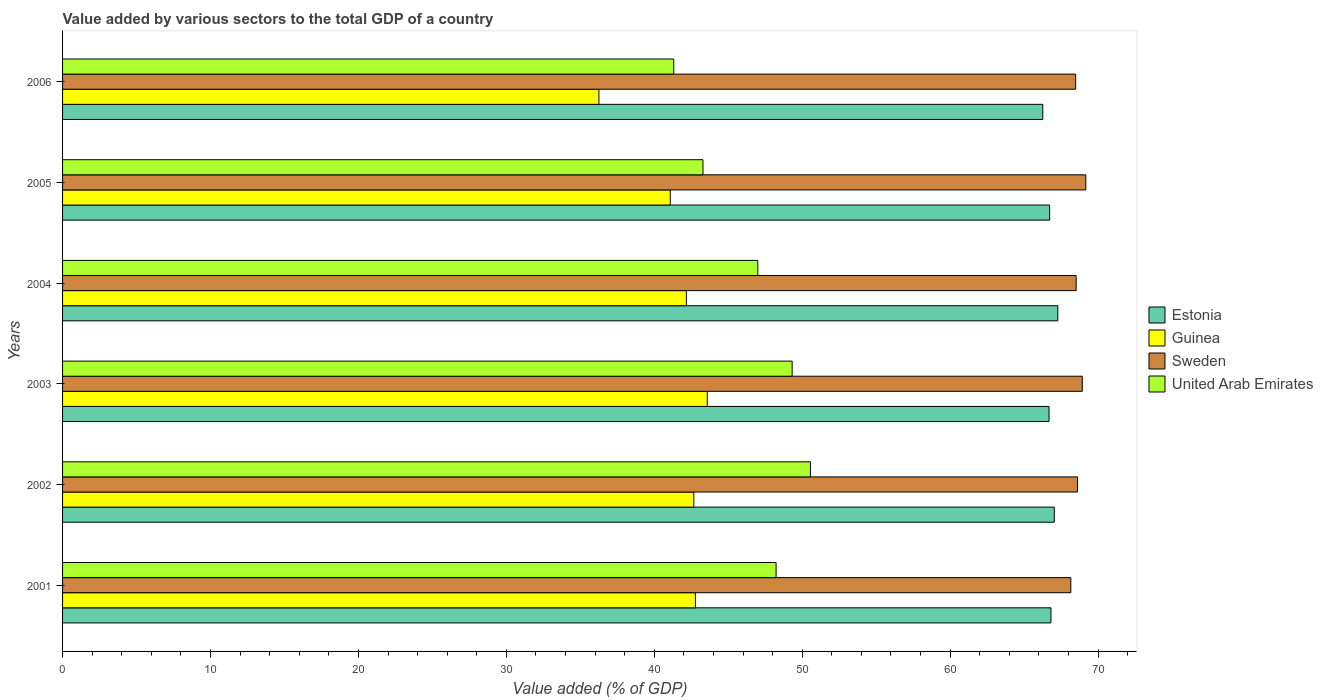How many different coloured bars are there?
Your answer should be very brief. 4. How many groups of bars are there?
Your answer should be very brief. 6. What is the value added by various sectors to the total GDP in United Arab Emirates in 2002?
Your answer should be very brief. 50.56. Across all years, what is the maximum value added by various sectors to the total GDP in Estonia?
Your answer should be compact. 67.28. Across all years, what is the minimum value added by various sectors to the total GDP in Estonia?
Keep it short and to the point. 66.26. In which year was the value added by various sectors to the total GDP in Guinea minimum?
Your answer should be very brief. 2006. What is the total value added by various sectors to the total GDP in Guinea in the graph?
Provide a succinct answer. 248.54. What is the difference between the value added by various sectors to the total GDP in Sweden in 2005 and that in 2006?
Make the answer very short. 0.69. What is the difference between the value added by various sectors to the total GDP in Guinea in 2004 and the value added by various sectors to the total GDP in Estonia in 2006?
Offer a very short reply. -24.09. What is the average value added by various sectors to the total GDP in Estonia per year?
Your answer should be very brief. 66.8. In the year 2003, what is the difference between the value added by various sectors to the total GDP in Guinea and value added by various sectors to the total GDP in Estonia?
Provide a succinct answer. -23.1. In how many years, is the value added by various sectors to the total GDP in Estonia greater than 32 %?
Offer a terse response. 6. What is the ratio of the value added by various sectors to the total GDP in Sweden in 2001 to that in 2003?
Ensure brevity in your answer.  0.99. Is the value added by various sectors to the total GDP in Guinea in 2003 less than that in 2004?
Make the answer very short. No. What is the difference between the highest and the second highest value added by various sectors to the total GDP in United Arab Emirates?
Offer a very short reply. 1.24. What is the difference between the highest and the lowest value added by various sectors to the total GDP in United Arab Emirates?
Your answer should be very brief. 9.24. In how many years, is the value added by various sectors to the total GDP in United Arab Emirates greater than the average value added by various sectors to the total GDP in United Arab Emirates taken over all years?
Provide a succinct answer. 4. What does the 4th bar from the top in 2005 represents?
Offer a very short reply. Estonia. What does the 1st bar from the bottom in 2003 represents?
Keep it short and to the point. Estonia. How many years are there in the graph?
Offer a very short reply. 6. Does the graph contain any zero values?
Offer a very short reply. No. Does the graph contain grids?
Provide a short and direct response. No. Where does the legend appear in the graph?
Keep it short and to the point. Center right. How many legend labels are there?
Provide a succinct answer. 4. How are the legend labels stacked?
Your answer should be very brief. Vertical. What is the title of the graph?
Provide a succinct answer. Value added by various sectors to the total GDP of a country. What is the label or title of the X-axis?
Your response must be concise. Value added (% of GDP). What is the label or title of the Y-axis?
Make the answer very short. Years. What is the Value added (% of GDP) in Estonia in 2001?
Provide a succinct answer. 66.81. What is the Value added (% of GDP) in Guinea in 2001?
Offer a terse response. 42.78. What is the Value added (% of GDP) of Sweden in 2001?
Your answer should be compact. 68.16. What is the Value added (% of GDP) of United Arab Emirates in 2001?
Provide a short and direct response. 48.23. What is the Value added (% of GDP) in Estonia in 2002?
Provide a succinct answer. 67.04. What is the Value added (% of GDP) in Guinea in 2002?
Make the answer very short. 42.67. What is the Value added (% of GDP) in Sweden in 2002?
Keep it short and to the point. 68.61. What is the Value added (% of GDP) in United Arab Emirates in 2002?
Offer a very short reply. 50.56. What is the Value added (% of GDP) of Estonia in 2003?
Make the answer very short. 66.68. What is the Value added (% of GDP) of Guinea in 2003?
Give a very brief answer. 43.58. What is the Value added (% of GDP) of Sweden in 2003?
Ensure brevity in your answer.  68.93. What is the Value added (% of GDP) of United Arab Emirates in 2003?
Provide a succinct answer. 49.32. What is the Value added (% of GDP) in Estonia in 2004?
Give a very brief answer. 67.28. What is the Value added (% of GDP) in Guinea in 2004?
Your answer should be compact. 42.17. What is the Value added (% of GDP) of Sweden in 2004?
Offer a very short reply. 68.52. What is the Value added (% of GDP) of United Arab Emirates in 2004?
Give a very brief answer. 47. What is the Value added (% of GDP) of Estonia in 2005?
Provide a short and direct response. 66.72. What is the Value added (% of GDP) of Guinea in 2005?
Provide a succinct answer. 41.08. What is the Value added (% of GDP) in Sweden in 2005?
Your answer should be very brief. 69.17. What is the Value added (% of GDP) of United Arab Emirates in 2005?
Keep it short and to the point. 43.29. What is the Value added (% of GDP) of Estonia in 2006?
Provide a short and direct response. 66.26. What is the Value added (% of GDP) of Guinea in 2006?
Offer a very short reply. 36.26. What is the Value added (% of GDP) of Sweden in 2006?
Your response must be concise. 68.48. What is the Value added (% of GDP) of United Arab Emirates in 2006?
Offer a terse response. 41.32. Across all years, what is the maximum Value added (% of GDP) in Estonia?
Your answer should be compact. 67.28. Across all years, what is the maximum Value added (% of GDP) of Guinea?
Give a very brief answer. 43.58. Across all years, what is the maximum Value added (% of GDP) of Sweden?
Your response must be concise. 69.17. Across all years, what is the maximum Value added (% of GDP) in United Arab Emirates?
Your answer should be compact. 50.56. Across all years, what is the minimum Value added (% of GDP) in Estonia?
Your answer should be compact. 66.26. Across all years, what is the minimum Value added (% of GDP) of Guinea?
Your answer should be compact. 36.26. Across all years, what is the minimum Value added (% of GDP) of Sweden?
Give a very brief answer. 68.16. Across all years, what is the minimum Value added (% of GDP) in United Arab Emirates?
Give a very brief answer. 41.32. What is the total Value added (% of GDP) of Estonia in the graph?
Provide a short and direct response. 400.8. What is the total Value added (% of GDP) of Guinea in the graph?
Provide a short and direct response. 248.54. What is the total Value added (% of GDP) of Sweden in the graph?
Your response must be concise. 411.87. What is the total Value added (% of GDP) of United Arab Emirates in the graph?
Offer a terse response. 279.71. What is the difference between the Value added (% of GDP) in Estonia in 2001 and that in 2002?
Your answer should be compact. -0.22. What is the difference between the Value added (% of GDP) in Guinea in 2001 and that in 2002?
Your answer should be compact. 0.11. What is the difference between the Value added (% of GDP) in Sweden in 2001 and that in 2002?
Offer a terse response. -0.45. What is the difference between the Value added (% of GDP) of United Arab Emirates in 2001 and that in 2002?
Offer a very short reply. -2.32. What is the difference between the Value added (% of GDP) of Estonia in 2001 and that in 2003?
Provide a short and direct response. 0.13. What is the difference between the Value added (% of GDP) in Guinea in 2001 and that in 2003?
Your answer should be very brief. -0.8. What is the difference between the Value added (% of GDP) of Sweden in 2001 and that in 2003?
Ensure brevity in your answer.  -0.78. What is the difference between the Value added (% of GDP) in United Arab Emirates in 2001 and that in 2003?
Offer a terse response. -1.08. What is the difference between the Value added (% of GDP) of Estonia in 2001 and that in 2004?
Provide a succinct answer. -0.46. What is the difference between the Value added (% of GDP) of Guinea in 2001 and that in 2004?
Provide a short and direct response. 0.61. What is the difference between the Value added (% of GDP) in Sweden in 2001 and that in 2004?
Your answer should be very brief. -0.36. What is the difference between the Value added (% of GDP) in United Arab Emirates in 2001 and that in 2004?
Provide a short and direct response. 1.24. What is the difference between the Value added (% of GDP) of Estonia in 2001 and that in 2005?
Your answer should be compact. 0.09. What is the difference between the Value added (% of GDP) of Guinea in 2001 and that in 2005?
Your response must be concise. 1.7. What is the difference between the Value added (% of GDP) in Sweden in 2001 and that in 2005?
Offer a terse response. -1.01. What is the difference between the Value added (% of GDP) of United Arab Emirates in 2001 and that in 2005?
Your answer should be very brief. 4.94. What is the difference between the Value added (% of GDP) in Estonia in 2001 and that in 2006?
Keep it short and to the point. 0.55. What is the difference between the Value added (% of GDP) in Guinea in 2001 and that in 2006?
Make the answer very short. 6.52. What is the difference between the Value added (% of GDP) of Sweden in 2001 and that in 2006?
Ensure brevity in your answer.  -0.33. What is the difference between the Value added (% of GDP) in United Arab Emirates in 2001 and that in 2006?
Provide a succinct answer. 6.92. What is the difference between the Value added (% of GDP) in Estonia in 2002 and that in 2003?
Keep it short and to the point. 0.35. What is the difference between the Value added (% of GDP) of Guinea in 2002 and that in 2003?
Make the answer very short. -0.91. What is the difference between the Value added (% of GDP) of Sweden in 2002 and that in 2003?
Provide a succinct answer. -0.32. What is the difference between the Value added (% of GDP) of United Arab Emirates in 2002 and that in 2003?
Make the answer very short. 1.24. What is the difference between the Value added (% of GDP) in Estonia in 2002 and that in 2004?
Provide a succinct answer. -0.24. What is the difference between the Value added (% of GDP) in Guinea in 2002 and that in 2004?
Make the answer very short. 0.5. What is the difference between the Value added (% of GDP) of Sweden in 2002 and that in 2004?
Your answer should be very brief. 0.09. What is the difference between the Value added (% of GDP) of United Arab Emirates in 2002 and that in 2004?
Your answer should be very brief. 3.56. What is the difference between the Value added (% of GDP) of Estonia in 2002 and that in 2005?
Provide a short and direct response. 0.31. What is the difference between the Value added (% of GDP) of Guinea in 2002 and that in 2005?
Make the answer very short. 1.59. What is the difference between the Value added (% of GDP) of Sweden in 2002 and that in 2005?
Provide a succinct answer. -0.56. What is the difference between the Value added (% of GDP) of United Arab Emirates in 2002 and that in 2005?
Your response must be concise. 7.26. What is the difference between the Value added (% of GDP) of Estonia in 2002 and that in 2006?
Ensure brevity in your answer.  0.78. What is the difference between the Value added (% of GDP) of Guinea in 2002 and that in 2006?
Provide a short and direct response. 6.42. What is the difference between the Value added (% of GDP) of Sweden in 2002 and that in 2006?
Provide a succinct answer. 0.13. What is the difference between the Value added (% of GDP) in United Arab Emirates in 2002 and that in 2006?
Your response must be concise. 9.24. What is the difference between the Value added (% of GDP) in Estonia in 2003 and that in 2004?
Your answer should be very brief. -0.59. What is the difference between the Value added (% of GDP) of Guinea in 2003 and that in 2004?
Your answer should be very brief. 1.41. What is the difference between the Value added (% of GDP) in Sweden in 2003 and that in 2004?
Keep it short and to the point. 0.42. What is the difference between the Value added (% of GDP) in United Arab Emirates in 2003 and that in 2004?
Keep it short and to the point. 2.32. What is the difference between the Value added (% of GDP) in Estonia in 2003 and that in 2005?
Offer a very short reply. -0.04. What is the difference between the Value added (% of GDP) of Guinea in 2003 and that in 2005?
Your answer should be compact. 2.5. What is the difference between the Value added (% of GDP) in Sweden in 2003 and that in 2005?
Make the answer very short. -0.24. What is the difference between the Value added (% of GDP) of United Arab Emirates in 2003 and that in 2005?
Give a very brief answer. 6.03. What is the difference between the Value added (% of GDP) in Estonia in 2003 and that in 2006?
Give a very brief answer. 0.42. What is the difference between the Value added (% of GDP) of Guinea in 2003 and that in 2006?
Offer a terse response. 7.33. What is the difference between the Value added (% of GDP) of Sweden in 2003 and that in 2006?
Offer a very short reply. 0.45. What is the difference between the Value added (% of GDP) of United Arab Emirates in 2003 and that in 2006?
Provide a succinct answer. 8. What is the difference between the Value added (% of GDP) of Estonia in 2004 and that in 2005?
Your response must be concise. 0.55. What is the difference between the Value added (% of GDP) in Guinea in 2004 and that in 2005?
Your answer should be compact. 1.09. What is the difference between the Value added (% of GDP) in Sweden in 2004 and that in 2005?
Your response must be concise. -0.65. What is the difference between the Value added (% of GDP) of United Arab Emirates in 2004 and that in 2005?
Offer a terse response. 3.71. What is the difference between the Value added (% of GDP) of Estonia in 2004 and that in 2006?
Give a very brief answer. 1.02. What is the difference between the Value added (% of GDP) of Guinea in 2004 and that in 2006?
Ensure brevity in your answer.  5.91. What is the difference between the Value added (% of GDP) in Sweden in 2004 and that in 2006?
Offer a terse response. 0.03. What is the difference between the Value added (% of GDP) in United Arab Emirates in 2004 and that in 2006?
Your answer should be very brief. 5.68. What is the difference between the Value added (% of GDP) in Estonia in 2005 and that in 2006?
Your response must be concise. 0.46. What is the difference between the Value added (% of GDP) in Guinea in 2005 and that in 2006?
Provide a succinct answer. 4.83. What is the difference between the Value added (% of GDP) of Sweden in 2005 and that in 2006?
Your response must be concise. 0.69. What is the difference between the Value added (% of GDP) in United Arab Emirates in 2005 and that in 2006?
Your answer should be compact. 1.98. What is the difference between the Value added (% of GDP) of Estonia in 2001 and the Value added (% of GDP) of Guinea in 2002?
Your response must be concise. 24.14. What is the difference between the Value added (% of GDP) of Estonia in 2001 and the Value added (% of GDP) of Sweden in 2002?
Offer a terse response. -1.8. What is the difference between the Value added (% of GDP) of Estonia in 2001 and the Value added (% of GDP) of United Arab Emirates in 2002?
Your answer should be very brief. 16.26. What is the difference between the Value added (% of GDP) of Guinea in 2001 and the Value added (% of GDP) of Sweden in 2002?
Make the answer very short. -25.83. What is the difference between the Value added (% of GDP) of Guinea in 2001 and the Value added (% of GDP) of United Arab Emirates in 2002?
Your response must be concise. -7.78. What is the difference between the Value added (% of GDP) in Sweden in 2001 and the Value added (% of GDP) in United Arab Emirates in 2002?
Offer a terse response. 17.6. What is the difference between the Value added (% of GDP) in Estonia in 2001 and the Value added (% of GDP) in Guinea in 2003?
Your answer should be very brief. 23.23. What is the difference between the Value added (% of GDP) of Estonia in 2001 and the Value added (% of GDP) of Sweden in 2003?
Ensure brevity in your answer.  -2.12. What is the difference between the Value added (% of GDP) in Estonia in 2001 and the Value added (% of GDP) in United Arab Emirates in 2003?
Ensure brevity in your answer.  17.5. What is the difference between the Value added (% of GDP) in Guinea in 2001 and the Value added (% of GDP) in Sweden in 2003?
Provide a succinct answer. -26.15. What is the difference between the Value added (% of GDP) in Guinea in 2001 and the Value added (% of GDP) in United Arab Emirates in 2003?
Your response must be concise. -6.54. What is the difference between the Value added (% of GDP) in Sweden in 2001 and the Value added (% of GDP) in United Arab Emirates in 2003?
Your response must be concise. 18.84. What is the difference between the Value added (% of GDP) in Estonia in 2001 and the Value added (% of GDP) in Guinea in 2004?
Keep it short and to the point. 24.64. What is the difference between the Value added (% of GDP) in Estonia in 2001 and the Value added (% of GDP) in Sweden in 2004?
Your answer should be very brief. -1.7. What is the difference between the Value added (% of GDP) in Estonia in 2001 and the Value added (% of GDP) in United Arab Emirates in 2004?
Offer a terse response. 19.82. What is the difference between the Value added (% of GDP) of Guinea in 2001 and the Value added (% of GDP) of Sweden in 2004?
Keep it short and to the point. -25.74. What is the difference between the Value added (% of GDP) in Guinea in 2001 and the Value added (% of GDP) in United Arab Emirates in 2004?
Ensure brevity in your answer.  -4.22. What is the difference between the Value added (% of GDP) in Sweden in 2001 and the Value added (% of GDP) in United Arab Emirates in 2004?
Make the answer very short. 21.16. What is the difference between the Value added (% of GDP) of Estonia in 2001 and the Value added (% of GDP) of Guinea in 2005?
Your answer should be very brief. 25.73. What is the difference between the Value added (% of GDP) of Estonia in 2001 and the Value added (% of GDP) of Sweden in 2005?
Provide a succinct answer. -2.36. What is the difference between the Value added (% of GDP) of Estonia in 2001 and the Value added (% of GDP) of United Arab Emirates in 2005?
Offer a very short reply. 23.52. What is the difference between the Value added (% of GDP) of Guinea in 2001 and the Value added (% of GDP) of Sweden in 2005?
Give a very brief answer. -26.39. What is the difference between the Value added (% of GDP) of Guinea in 2001 and the Value added (% of GDP) of United Arab Emirates in 2005?
Ensure brevity in your answer.  -0.51. What is the difference between the Value added (% of GDP) in Sweden in 2001 and the Value added (% of GDP) in United Arab Emirates in 2005?
Your answer should be compact. 24.86. What is the difference between the Value added (% of GDP) in Estonia in 2001 and the Value added (% of GDP) in Guinea in 2006?
Your response must be concise. 30.56. What is the difference between the Value added (% of GDP) of Estonia in 2001 and the Value added (% of GDP) of Sweden in 2006?
Keep it short and to the point. -1.67. What is the difference between the Value added (% of GDP) in Estonia in 2001 and the Value added (% of GDP) in United Arab Emirates in 2006?
Make the answer very short. 25.5. What is the difference between the Value added (% of GDP) in Guinea in 2001 and the Value added (% of GDP) in Sweden in 2006?
Offer a terse response. -25.7. What is the difference between the Value added (% of GDP) of Guinea in 2001 and the Value added (% of GDP) of United Arab Emirates in 2006?
Provide a succinct answer. 1.46. What is the difference between the Value added (% of GDP) of Sweden in 2001 and the Value added (% of GDP) of United Arab Emirates in 2006?
Provide a succinct answer. 26.84. What is the difference between the Value added (% of GDP) in Estonia in 2002 and the Value added (% of GDP) in Guinea in 2003?
Your answer should be very brief. 23.46. What is the difference between the Value added (% of GDP) in Estonia in 2002 and the Value added (% of GDP) in Sweden in 2003?
Give a very brief answer. -1.89. What is the difference between the Value added (% of GDP) of Estonia in 2002 and the Value added (% of GDP) of United Arab Emirates in 2003?
Provide a short and direct response. 17.72. What is the difference between the Value added (% of GDP) of Guinea in 2002 and the Value added (% of GDP) of Sweden in 2003?
Provide a succinct answer. -26.26. What is the difference between the Value added (% of GDP) in Guinea in 2002 and the Value added (% of GDP) in United Arab Emirates in 2003?
Make the answer very short. -6.65. What is the difference between the Value added (% of GDP) in Sweden in 2002 and the Value added (% of GDP) in United Arab Emirates in 2003?
Provide a succinct answer. 19.29. What is the difference between the Value added (% of GDP) in Estonia in 2002 and the Value added (% of GDP) in Guinea in 2004?
Make the answer very short. 24.87. What is the difference between the Value added (% of GDP) of Estonia in 2002 and the Value added (% of GDP) of Sweden in 2004?
Give a very brief answer. -1.48. What is the difference between the Value added (% of GDP) of Estonia in 2002 and the Value added (% of GDP) of United Arab Emirates in 2004?
Provide a short and direct response. 20.04. What is the difference between the Value added (% of GDP) of Guinea in 2002 and the Value added (% of GDP) of Sweden in 2004?
Offer a terse response. -25.84. What is the difference between the Value added (% of GDP) in Guinea in 2002 and the Value added (% of GDP) in United Arab Emirates in 2004?
Provide a succinct answer. -4.32. What is the difference between the Value added (% of GDP) in Sweden in 2002 and the Value added (% of GDP) in United Arab Emirates in 2004?
Your response must be concise. 21.61. What is the difference between the Value added (% of GDP) of Estonia in 2002 and the Value added (% of GDP) of Guinea in 2005?
Make the answer very short. 25.96. What is the difference between the Value added (% of GDP) in Estonia in 2002 and the Value added (% of GDP) in Sweden in 2005?
Keep it short and to the point. -2.13. What is the difference between the Value added (% of GDP) in Estonia in 2002 and the Value added (% of GDP) in United Arab Emirates in 2005?
Offer a terse response. 23.75. What is the difference between the Value added (% of GDP) in Guinea in 2002 and the Value added (% of GDP) in Sweden in 2005?
Provide a short and direct response. -26.5. What is the difference between the Value added (% of GDP) in Guinea in 2002 and the Value added (% of GDP) in United Arab Emirates in 2005?
Ensure brevity in your answer.  -0.62. What is the difference between the Value added (% of GDP) of Sweden in 2002 and the Value added (% of GDP) of United Arab Emirates in 2005?
Make the answer very short. 25.32. What is the difference between the Value added (% of GDP) of Estonia in 2002 and the Value added (% of GDP) of Guinea in 2006?
Provide a succinct answer. 30.78. What is the difference between the Value added (% of GDP) of Estonia in 2002 and the Value added (% of GDP) of Sweden in 2006?
Your answer should be compact. -1.45. What is the difference between the Value added (% of GDP) in Estonia in 2002 and the Value added (% of GDP) in United Arab Emirates in 2006?
Offer a very short reply. 25.72. What is the difference between the Value added (% of GDP) of Guinea in 2002 and the Value added (% of GDP) of Sweden in 2006?
Your answer should be compact. -25.81. What is the difference between the Value added (% of GDP) in Guinea in 2002 and the Value added (% of GDP) in United Arab Emirates in 2006?
Make the answer very short. 1.36. What is the difference between the Value added (% of GDP) of Sweden in 2002 and the Value added (% of GDP) of United Arab Emirates in 2006?
Keep it short and to the point. 27.3. What is the difference between the Value added (% of GDP) in Estonia in 2003 and the Value added (% of GDP) in Guinea in 2004?
Offer a very short reply. 24.52. What is the difference between the Value added (% of GDP) in Estonia in 2003 and the Value added (% of GDP) in Sweden in 2004?
Offer a very short reply. -1.83. What is the difference between the Value added (% of GDP) in Estonia in 2003 and the Value added (% of GDP) in United Arab Emirates in 2004?
Your response must be concise. 19.69. What is the difference between the Value added (% of GDP) of Guinea in 2003 and the Value added (% of GDP) of Sweden in 2004?
Offer a very short reply. -24.93. What is the difference between the Value added (% of GDP) in Guinea in 2003 and the Value added (% of GDP) in United Arab Emirates in 2004?
Provide a short and direct response. -3.41. What is the difference between the Value added (% of GDP) of Sweden in 2003 and the Value added (% of GDP) of United Arab Emirates in 2004?
Provide a succinct answer. 21.94. What is the difference between the Value added (% of GDP) in Estonia in 2003 and the Value added (% of GDP) in Guinea in 2005?
Provide a succinct answer. 25.6. What is the difference between the Value added (% of GDP) of Estonia in 2003 and the Value added (% of GDP) of Sweden in 2005?
Make the answer very short. -2.49. What is the difference between the Value added (% of GDP) in Estonia in 2003 and the Value added (% of GDP) in United Arab Emirates in 2005?
Give a very brief answer. 23.39. What is the difference between the Value added (% of GDP) of Guinea in 2003 and the Value added (% of GDP) of Sweden in 2005?
Keep it short and to the point. -25.59. What is the difference between the Value added (% of GDP) of Guinea in 2003 and the Value added (% of GDP) of United Arab Emirates in 2005?
Make the answer very short. 0.29. What is the difference between the Value added (% of GDP) of Sweden in 2003 and the Value added (% of GDP) of United Arab Emirates in 2005?
Offer a terse response. 25.64. What is the difference between the Value added (% of GDP) of Estonia in 2003 and the Value added (% of GDP) of Guinea in 2006?
Your response must be concise. 30.43. What is the difference between the Value added (% of GDP) of Estonia in 2003 and the Value added (% of GDP) of Sweden in 2006?
Provide a short and direct response. -1.8. What is the difference between the Value added (% of GDP) in Estonia in 2003 and the Value added (% of GDP) in United Arab Emirates in 2006?
Ensure brevity in your answer.  25.37. What is the difference between the Value added (% of GDP) in Guinea in 2003 and the Value added (% of GDP) in Sweden in 2006?
Your response must be concise. -24.9. What is the difference between the Value added (% of GDP) of Guinea in 2003 and the Value added (% of GDP) of United Arab Emirates in 2006?
Keep it short and to the point. 2.27. What is the difference between the Value added (% of GDP) in Sweden in 2003 and the Value added (% of GDP) in United Arab Emirates in 2006?
Provide a succinct answer. 27.62. What is the difference between the Value added (% of GDP) in Estonia in 2004 and the Value added (% of GDP) in Guinea in 2005?
Offer a very short reply. 26.2. What is the difference between the Value added (% of GDP) of Estonia in 2004 and the Value added (% of GDP) of Sweden in 2005?
Offer a very short reply. -1.89. What is the difference between the Value added (% of GDP) of Estonia in 2004 and the Value added (% of GDP) of United Arab Emirates in 2005?
Give a very brief answer. 23.99. What is the difference between the Value added (% of GDP) in Guinea in 2004 and the Value added (% of GDP) in Sweden in 2005?
Give a very brief answer. -27. What is the difference between the Value added (% of GDP) of Guinea in 2004 and the Value added (% of GDP) of United Arab Emirates in 2005?
Your answer should be very brief. -1.12. What is the difference between the Value added (% of GDP) of Sweden in 2004 and the Value added (% of GDP) of United Arab Emirates in 2005?
Ensure brevity in your answer.  25.22. What is the difference between the Value added (% of GDP) in Estonia in 2004 and the Value added (% of GDP) in Guinea in 2006?
Make the answer very short. 31.02. What is the difference between the Value added (% of GDP) in Estonia in 2004 and the Value added (% of GDP) in Sweden in 2006?
Your answer should be very brief. -1.21. What is the difference between the Value added (% of GDP) of Estonia in 2004 and the Value added (% of GDP) of United Arab Emirates in 2006?
Your answer should be very brief. 25.96. What is the difference between the Value added (% of GDP) in Guinea in 2004 and the Value added (% of GDP) in Sweden in 2006?
Give a very brief answer. -26.32. What is the difference between the Value added (% of GDP) of Guinea in 2004 and the Value added (% of GDP) of United Arab Emirates in 2006?
Provide a succinct answer. 0.85. What is the difference between the Value added (% of GDP) of Sweden in 2004 and the Value added (% of GDP) of United Arab Emirates in 2006?
Make the answer very short. 27.2. What is the difference between the Value added (% of GDP) in Estonia in 2005 and the Value added (% of GDP) in Guinea in 2006?
Offer a terse response. 30.47. What is the difference between the Value added (% of GDP) of Estonia in 2005 and the Value added (% of GDP) of Sweden in 2006?
Offer a very short reply. -1.76. What is the difference between the Value added (% of GDP) of Estonia in 2005 and the Value added (% of GDP) of United Arab Emirates in 2006?
Make the answer very short. 25.41. What is the difference between the Value added (% of GDP) in Guinea in 2005 and the Value added (% of GDP) in Sweden in 2006?
Provide a short and direct response. -27.4. What is the difference between the Value added (% of GDP) in Guinea in 2005 and the Value added (% of GDP) in United Arab Emirates in 2006?
Your answer should be compact. -0.23. What is the difference between the Value added (% of GDP) in Sweden in 2005 and the Value added (% of GDP) in United Arab Emirates in 2006?
Your answer should be very brief. 27.85. What is the average Value added (% of GDP) in Estonia per year?
Provide a short and direct response. 66.8. What is the average Value added (% of GDP) in Guinea per year?
Your response must be concise. 41.42. What is the average Value added (% of GDP) of Sweden per year?
Your response must be concise. 68.64. What is the average Value added (% of GDP) of United Arab Emirates per year?
Your response must be concise. 46.62. In the year 2001, what is the difference between the Value added (% of GDP) in Estonia and Value added (% of GDP) in Guinea?
Offer a terse response. 24.03. In the year 2001, what is the difference between the Value added (% of GDP) in Estonia and Value added (% of GDP) in Sweden?
Give a very brief answer. -1.34. In the year 2001, what is the difference between the Value added (% of GDP) of Estonia and Value added (% of GDP) of United Arab Emirates?
Provide a short and direct response. 18.58. In the year 2001, what is the difference between the Value added (% of GDP) in Guinea and Value added (% of GDP) in Sweden?
Offer a very short reply. -25.38. In the year 2001, what is the difference between the Value added (% of GDP) of Guinea and Value added (% of GDP) of United Arab Emirates?
Give a very brief answer. -5.45. In the year 2001, what is the difference between the Value added (% of GDP) in Sweden and Value added (% of GDP) in United Arab Emirates?
Keep it short and to the point. 19.92. In the year 2002, what is the difference between the Value added (% of GDP) of Estonia and Value added (% of GDP) of Guinea?
Give a very brief answer. 24.37. In the year 2002, what is the difference between the Value added (% of GDP) of Estonia and Value added (% of GDP) of Sweden?
Ensure brevity in your answer.  -1.57. In the year 2002, what is the difference between the Value added (% of GDP) of Estonia and Value added (% of GDP) of United Arab Emirates?
Your response must be concise. 16.48. In the year 2002, what is the difference between the Value added (% of GDP) in Guinea and Value added (% of GDP) in Sweden?
Provide a succinct answer. -25.94. In the year 2002, what is the difference between the Value added (% of GDP) of Guinea and Value added (% of GDP) of United Arab Emirates?
Your response must be concise. -7.88. In the year 2002, what is the difference between the Value added (% of GDP) of Sweden and Value added (% of GDP) of United Arab Emirates?
Your response must be concise. 18.06. In the year 2003, what is the difference between the Value added (% of GDP) in Estonia and Value added (% of GDP) in Guinea?
Your answer should be compact. 23.1. In the year 2003, what is the difference between the Value added (% of GDP) in Estonia and Value added (% of GDP) in Sweden?
Make the answer very short. -2.25. In the year 2003, what is the difference between the Value added (% of GDP) of Estonia and Value added (% of GDP) of United Arab Emirates?
Provide a succinct answer. 17.37. In the year 2003, what is the difference between the Value added (% of GDP) in Guinea and Value added (% of GDP) in Sweden?
Keep it short and to the point. -25.35. In the year 2003, what is the difference between the Value added (% of GDP) of Guinea and Value added (% of GDP) of United Arab Emirates?
Provide a succinct answer. -5.74. In the year 2003, what is the difference between the Value added (% of GDP) of Sweden and Value added (% of GDP) of United Arab Emirates?
Offer a very short reply. 19.61. In the year 2004, what is the difference between the Value added (% of GDP) in Estonia and Value added (% of GDP) in Guinea?
Ensure brevity in your answer.  25.11. In the year 2004, what is the difference between the Value added (% of GDP) of Estonia and Value added (% of GDP) of Sweden?
Provide a short and direct response. -1.24. In the year 2004, what is the difference between the Value added (% of GDP) in Estonia and Value added (% of GDP) in United Arab Emirates?
Your answer should be compact. 20.28. In the year 2004, what is the difference between the Value added (% of GDP) in Guinea and Value added (% of GDP) in Sweden?
Keep it short and to the point. -26.35. In the year 2004, what is the difference between the Value added (% of GDP) of Guinea and Value added (% of GDP) of United Arab Emirates?
Your response must be concise. -4.83. In the year 2004, what is the difference between the Value added (% of GDP) in Sweden and Value added (% of GDP) in United Arab Emirates?
Offer a terse response. 21.52. In the year 2005, what is the difference between the Value added (% of GDP) of Estonia and Value added (% of GDP) of Guinea?
Your answer should be compact. 25.64. In the year 2005, what is the difference between the Value added (% of GDP) in Estonia and Value added (% of GDP) in Sweden?
Your answer should be very brief. -2.45. In the year 2005, what is the difference between the Value added (% of GDP) in Estonia and Value added (% of GDP) in United Arab Emirates?
Make the answer very short. 23.43. In the year 2005, what is the difference between the Value added (% of GDP) in Guinea and Value added (% of GDP) in Sweden?
Provide a succinct answer. -28.09. In the year 2005, what is the difference between the Value added (% of GDP) of Guinea and Value added (% of GDP) of United Arab Emirates?
Make the answer very short. -2.21. In the year 2005, what is the difference between the Value added (% of GDP) of Sweden and Value added (% of GDP) of United Arab Emirates?
Give a very brief answer. 25.88. In the year 2006, what is the difference between the Value added (% of GDP) of Estonia and Value added (% of GDP) of Guinea?
Provide a short and direct response. 30.01. In the year 2006, what is the difference between the Value added (% of GDP) in Estonia and Value added (% of GDP) in Sweden?
Offer a terse response. -2.22. In the year 2006, what is the difference between the Value added (% of GDP) in Estonia and Value added (% of GDP) in United Arab Emirates?
Keep it short and to the point. 24.95. In the year 2006, what is the difference between the Value added (% of GDP) in Guinea and Value added (% of GDP) in Sweden?
Keep it short and to the point. -32.23. In the year 2006, what is the difference between the Value added (% of GDP) in Guinea and Value added (% of GDP) in United Arab Emirates?
Offer a terse response. -5.06. In the year 2006, what is the difference between the Value added (% of GDP) in Sweden and Value added (% of GDP) in United Arab Emirates?
Make the answer very short. 27.17. What is the ratio of the Value added (% of GDP) in Guinea in 2001 to that in 2002?
Your answer should be very brief. 1. What is the ratio of the Value added (% of GDP) of United Arab Emirates in 2001 to that in 2002?
Your response must be concise. 0.95. What is the ratio of the Value added (% of GDP) of Guinea in 2001 to that in 2003?
Keep it short and to the point. 0.98. What is the ratio of the Value added (% of GDP) of Sweden in 2001 to that in 2003?
Your answer should be very brief. 0.99. What is the ratio of the Value added (% of GDP) in United Arab Emirates in 2001 to that in 2003?
Your answer should be compact. 0.98. What is the ratio of the Value added (% of GDP) of Guinea in 2001 to that in 2004?
Keep it short and to the point. 1.01. What is the ratio of the Value added (% of GDP) in Sweden in 2001 to that in 2004?
Keep it short and to the point. 0.99. What is the ratio of the Value added (% of GDP) in United Arab Emirates in 2001 to that in 2004?
Offer a very short reply. 1.03. What is the ratio of the Value added (% of GDP) in Estonia in 2001 to that in 2005?
Keep it short and to the point. 1. What is the ratio of the Value added (% of GDP) of Guinea in 2001 to that in 2005?
Your answer should be very brief. 1.04. What is the ratio of the Value added (% of GDP) in Sweden in 2001 to that in 2005?
Ensure brevity in your answer.  0.99. What is the ratio of the Value added (% of GDP) in United Arab Emirates in 2001 to that in 2005?
Your answer should be very brief. 1.11. What is the ratio of the Value added (% of GDP) of Estonia in 2001 to that in 2006?
Ensure brevity in your answer.  1.01. What is the ratio of the Value added (% of GDP) of Guinea in 2001 to that in 2006?
Provide a short and direct response. 1.18. What is the ratio of the Value added (% of GDP) of United Arab Emirates in 2001 to that in 2006?
Your answer should be compact. 1.17. What is the ratio of the Value added (% of GDP) in Estonia in 2002 to that in 2003?
Offer a very short reply. 1.01. What is the ratio of the Value added (% of GDP) of Guinea in 2002 to that in 2003?
Give a very brief answer. 0.98. What is the ratio of the Value added (% of GDP) of Sweden in 2002 to that in 2003?
Provide a succinct answer. 1. What is the ratio of the Value added (% of GDP) of United Arab Emirates in 2002 to that in 2003?
Give a very brief answer. 1.03. What is the ratio of the Value added (% of GDP) in Estonia in 2002 to that in 2004?
Provide a succinct answer. 1. What is the ratio of the Value added (% of GDP) of Guinea in 2002 to that in 2004?
Your answer should be very brief. 1.01. What is the ratio of the Value added (% of GDP) in Sweden in 2002 to that in 2004?
Provide a short and direct response. 1. What is the ratio of the Value added (% of GDP) in United Arab Emirates in 2002 to that in 2004?
Give a very brief answer. 1.08. What is the ratio of the Value added (% of GDP) in Estonia in 2002 to that in 2005?
Your answer should be compact. 1. What is the ratio of the Value added (% of GDP) in Guinea in 2002 to that in 2005?
Ensure brevity in your answer.  1.04. What is the ratio of the Value added (% of GDP) in United Arab Emirates in 2002 to that in 2005?
Your answer should be very brief. 1.17. What is the ratio of the Value added (% of GDP) of Estonia in 2002 to that in 2006?
Provide a succinct answer. 1.01. What is the ratio of the Value added (% of GDP) of Guinea in 2002 to that in 2006?
Give a very brief answer. 1.18. What is the ratio of the Value added (% of GDP) in Sweden in 2002 to that in 2006?
Give a very brief answer. 1. What is the ratio of the Value added (% of GDP) of United Arab Emirates in 2002 to that in 2006?
Your response must be concise. 1.22. What is the ratio of the Value added (% of GDP) in Estonia in 2003 to that in 2004?
Provide a short and direct response. 0.99. What is the ratio of the Value added (% of GDP) in Guinea in 2003 to that in 2004?
Ensure brevity in your answer.  1.03. What is the ratio of the Value added (% of GDP) in Sweden in 2003 to that in 2004?
Provide a short and direct response. 1.01. What is the ratio of the Value added (% of GDP) of United Arab Emirates in 2003 to that in 2004?
Ensure brevity in your answer.  1.05. What is the ratio of the Value added (% of GDP) of Estonia in 2003 to that in 2005?
Your answer should be compact. 1. What is the ratio of the Value added (% of GDP) of Guinea in 2003 to that in 2005?
Your answer should be compact. 1.06. What is the ratio of the Value added (% of GDP) of United Arab Emirates in 2003 to that in 2005?
Provide a short and direct response. 1.14. What is the ratio of the Value added (% of GDP) of Estonia in 2003 to that in 2006?
Give a very brief answer. 1.01. What is the ratio of the Value added (% of GDP) in Guinea in 2003 to that in 2006?
Give a very brief answer. 1.2. What is the ratio of the Value added (% of GDP) in United Arab Emirates in 2003 to that in 2006?
Provide a succinct answer. 1.19. What is the ratio of the Value added (% of GDP) in Estonia in 2004 to that in 2005?
Make the answer very short. 1.01. What is the ratio of the Value added (% of GDP) of Guinea in 2004 to that in 2005?
Provide a short and direct response. 1.03. What is the ratio of the Value added (% of GDP) of Sweden in 2004 to that in 2005?
Ensure brevity in your answer.  0.99. What is the ratio of the Value added (% of GDP) in United Arab Emirates in 2004 to that in 2005?
Your response must be concise. 1.09. What is the ratio of the Value added (% of GDP) of Estonia in 2004 to that in 2006?
Your answer should be compact. 1.02. What is the ratio of the Value added (% of GDP) of Guinea in 2004 to that in 2006?
Give a very brief answer. 1.16. What is the ratio of the Value added (% of GDP) in Sweden in 2004 to that in 2006?
Give a very brief answer. 1. What is the ratio of the Value added (% of GDP) in United Arab Emirates in 2004 to that in 2006?
Keep it short and to the point. 1.14. What is the ratio of the Value added (% of GDP) of Estonia in 2005 to that in 2006?
Your answer should be very brief. 1.01. What is the ratio of the Value added (% of GDP) of Guinea in 2005 to that in 2006?
Provide a short and direct response. 1.13. What is the ratio of the Value added (% of GDP) of United Arab Emirates in 2005 to that in 2006?
Your answer should be very brief. 1.05. What is the difference between the highest and the second highest Value added (% of GDP) of Estonia?
Make the answer very short. 0.24. What is the difference between the highest and the second highest Value added (% of GDP) in Guinea?
Ensure brevity in your answer.  0.8. What is the difference between the highest and the second highest Value added (% of GDP) of Sweden?
Make the answer very short. 0.24. What is the difference between the highest and the second highest Value added (% of GDP) of United Arab Emirates?
Provide a short and direct response. 1.24. What is the difference between the highest and the lowest Value added (% of GDP) in Estonia?
Offer a very short reply. 1.02. What is the difference between the highest and the lowest Value added (% of GDP) in Guinea?
Offer a very short reply. 7.33. What is the difference between the highest and the lowest Value added (% of GDP) of Sweden?
Keep it short and to the point. 1.01. What is the difference between the highest and the lowest Value added (% of GDP) in United Arab Emirates?
Keep it short and to the point. 9.24. 